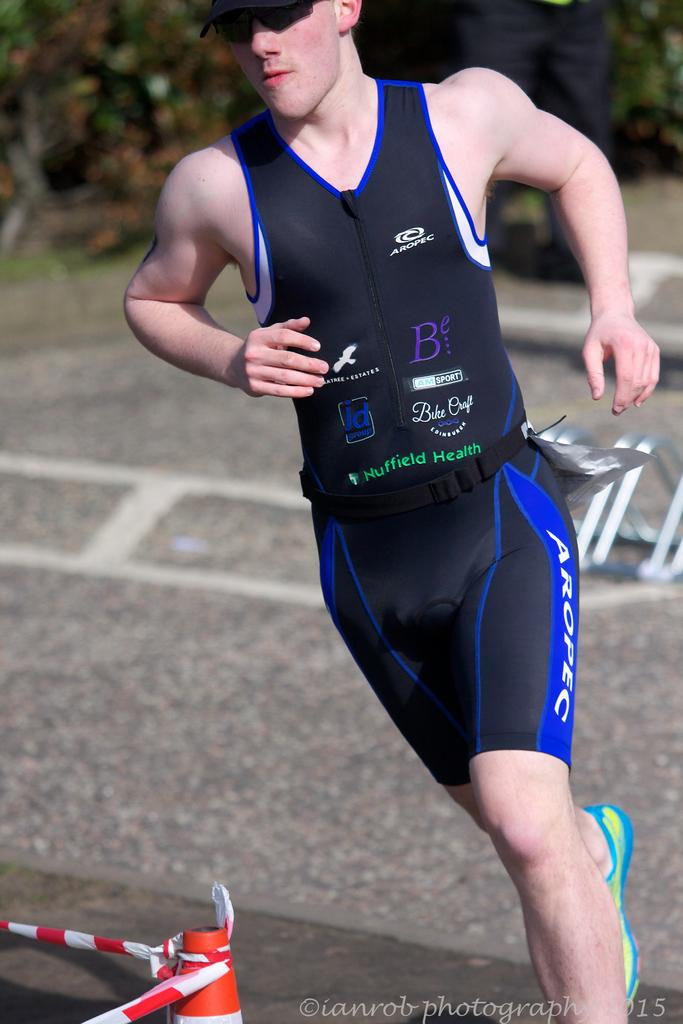Provide a one-sentence caption for the provided image. a runner in black aropec wear turning a corner. 